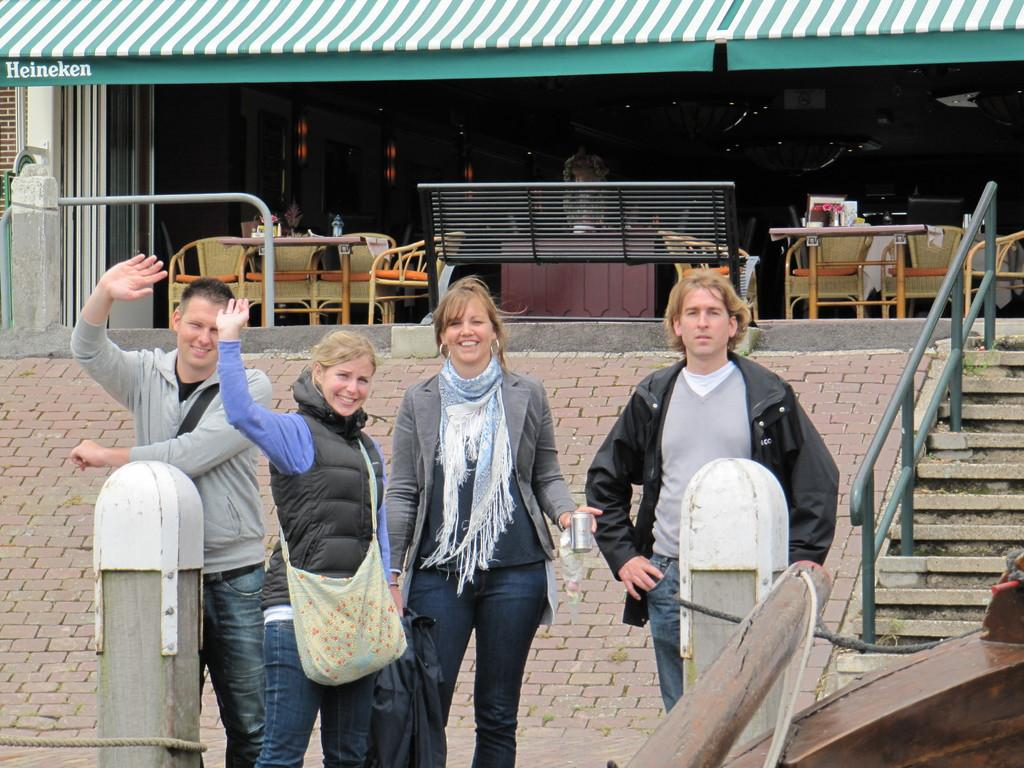What type of furniture is present in the image? There are tables and chairs in the image. What architectural feature can be seen in the image? There is a staircase in the image. What else is visible in the image besides furniture and the staircase? There are other objects in the image. Are there any people in the image? Yes, there are people in the image. What is the mood or expression of the people in the image? The people in the image are smiling. How many ducks are sitting on the staircase in the image? There are no ducks present in the image. What type of mark can be seen on the table in the image? There is no specific mark mentioned in the provided facts, so we cannot determine if there is a mark on the table. 